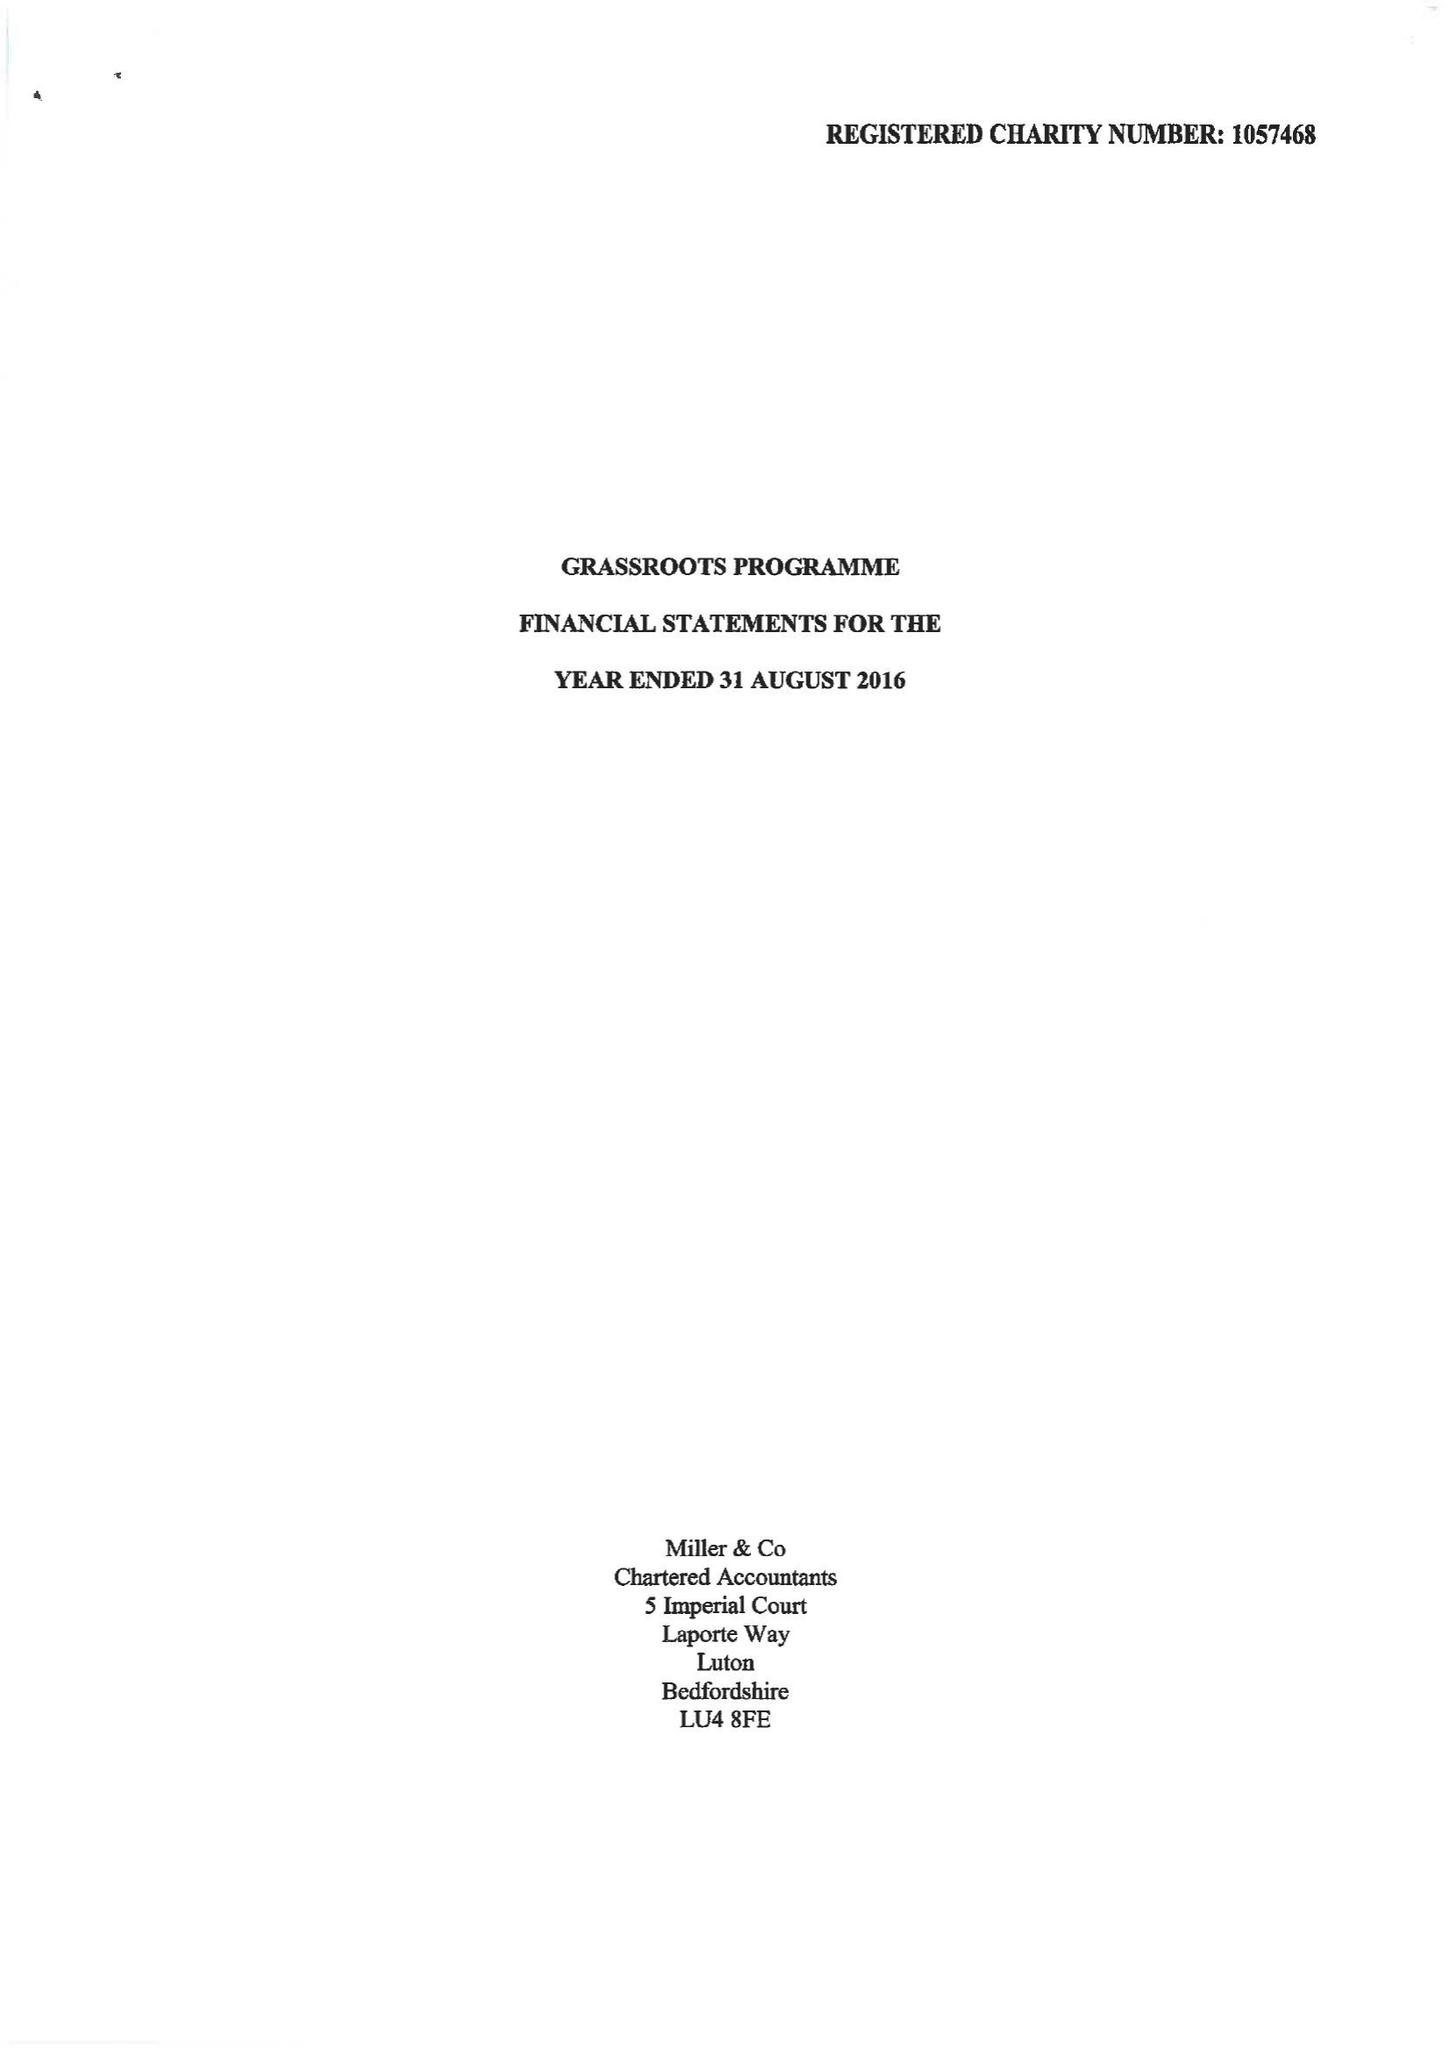What is the value for the charity_name?
Answer the question using a single word or phrase. Grassroots Programme 